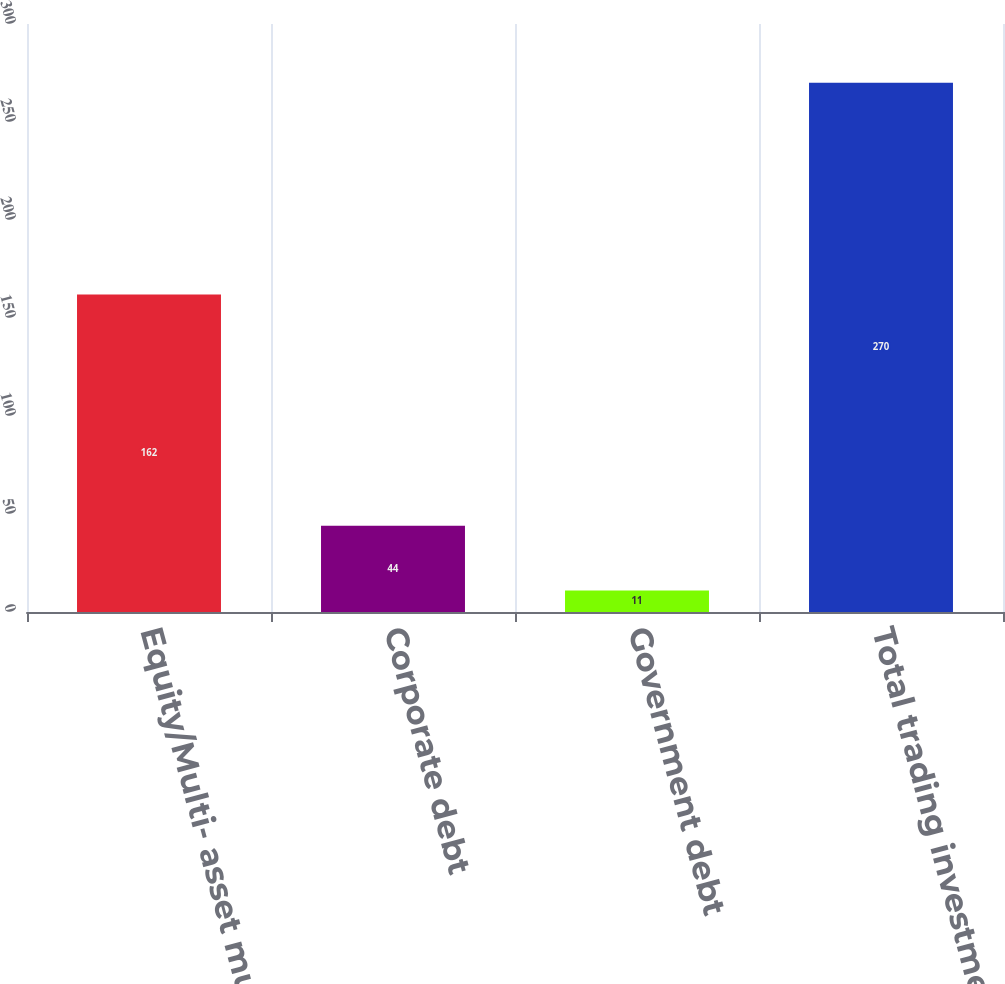<chart> <loc_0><loc_0><loc_500><loc_500><bar_chart><fcel>Equity/Multi- asset mutual<fcel>Corporate debt<fcel>Government debt<fcel>Total trading investments<nl><fcel>162<fcel>44<fcel>11<fcel>270<nl></chart> 